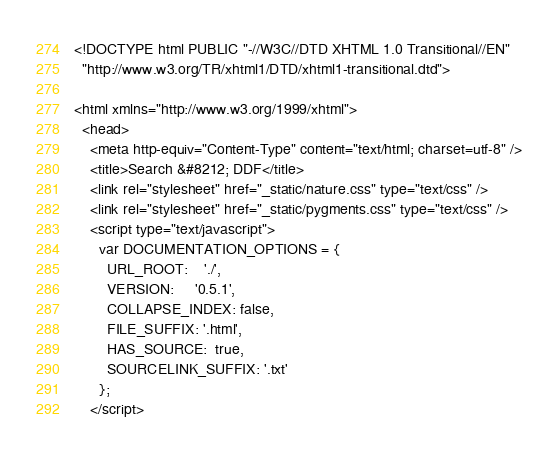<code> <loc_0><loc_0><loc_500><loc_500><_HTML_>
<!DOCTYPE html PUBLIC "-//W3C//DTD XHTML 1.0 Transitional//EN"
  "http://www.w3.org/TR/xhtml1/DTD/xhtml1-transitional.dtd">

<html xmlns="http://www.w3.org/1999/xhtml">
  <head>
    <meta http-equiv="Content-Type" content="text/html; charset=utf-8" />
    <title>Search &#8212; DDF</title>
    <link rel="stylesheet" href="_static/nature.css" type="text/css" />
    <link rel="stylesheet" href="_static/pygments.css" type="text/css" />
    <script type="text/javascript">
      var DOCUMENTATION_OPTIONS = {
        URL_ROOT:    './',
        VERSION:     '0.5.1',
        COLLAPSE_INDEX: false,
        FILE_SUFFIX: '.html',
        HAS_SOURCE:  true,
        SOURCELINK_SUFFIX: '.txt'
      };
    </script></code> 